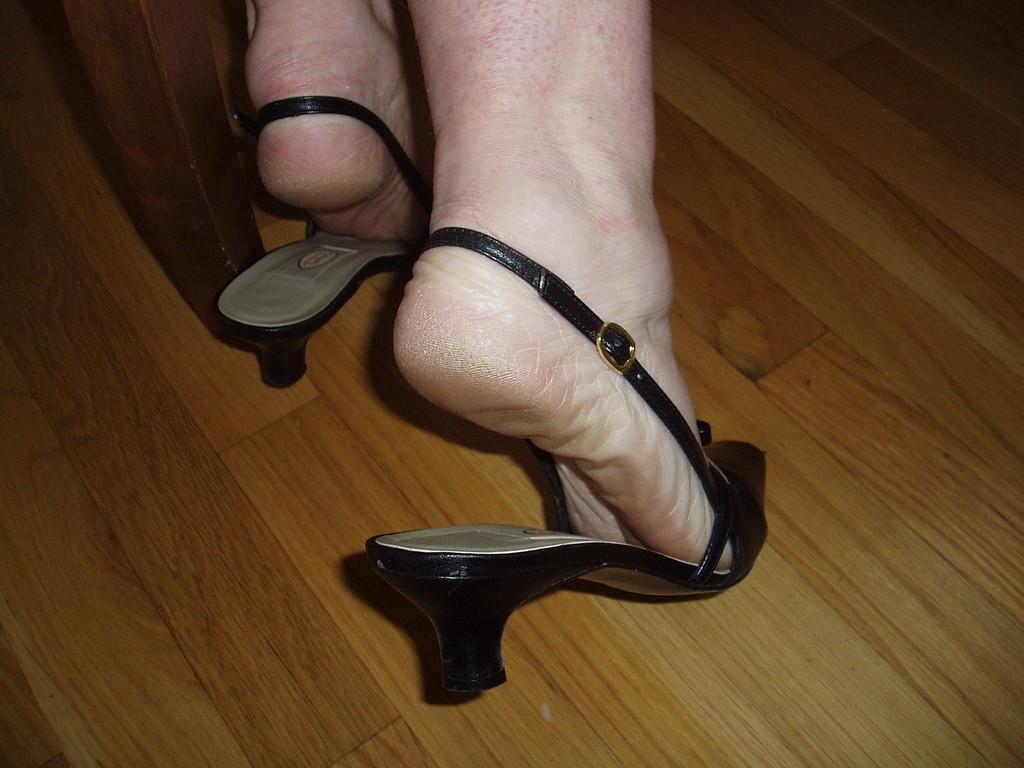Can you describe this image briefly? In this picture we can see a person's legs with sandals on the floor. 